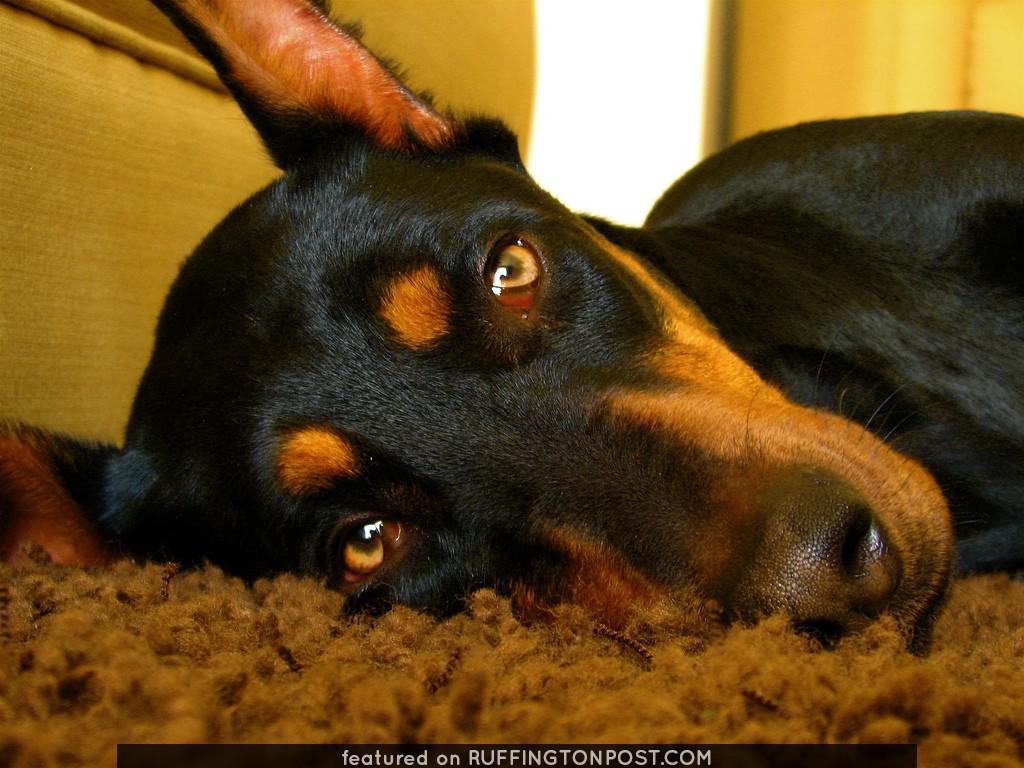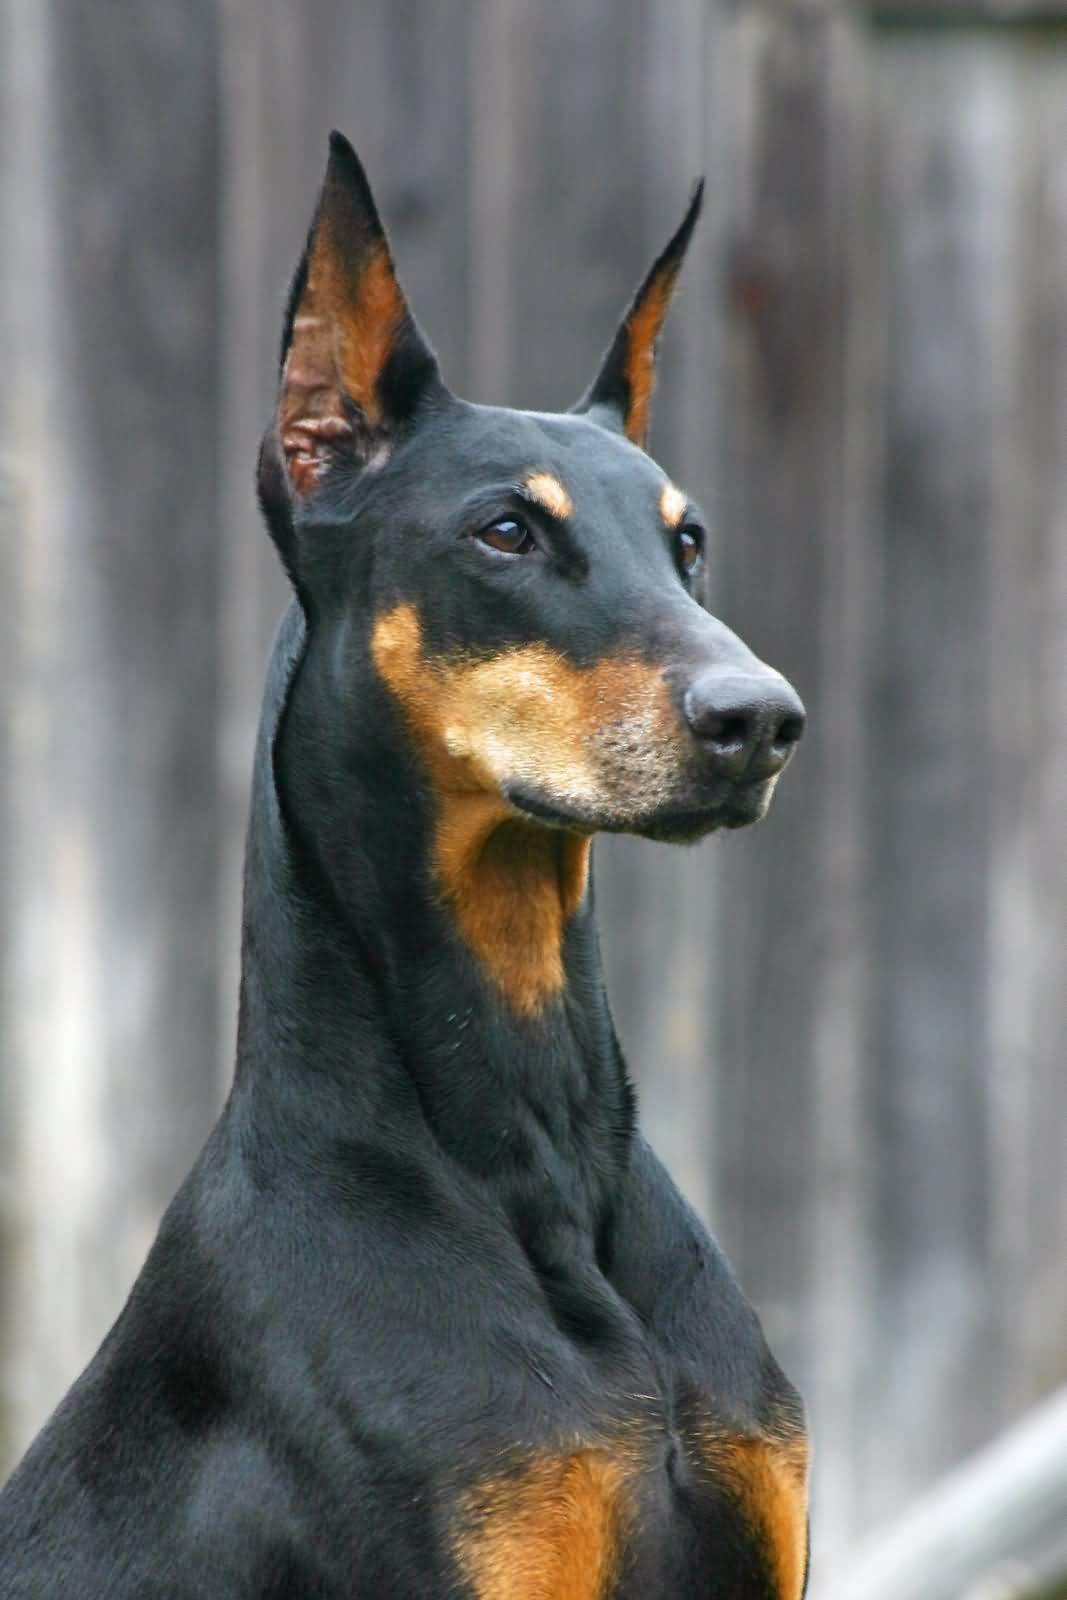The first image is the image on the left, the second image is the image on the right. Given the left and right images, does the statement "Each image contains one erect-eared doberman posed outdoors, and one image shows a standing dog with front feet elevated and body turned rightward in front of autumn colors." hold true? Answer yes or no. No. The first image is the image on the left, the second image is the image on the right. Assess this claim about the two images: "A dog is outside near a building in one of the buildings.". Correct or not? Answer yes or no. No. 